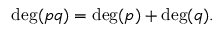<formula> <loc_0><loc_0><loc_500><loc_500>\deg ( p q ) = \deg ( p ) + \deg ( q ) .</formula> 